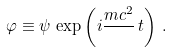Convert formula to latex. <formula><loc_0><loc_0><loc_500><loc_500>\varphi \equiv \psi \, \exp \left ( i \frac { m c ^ { 2 } } { } \, t \right ) \, .</formula> 